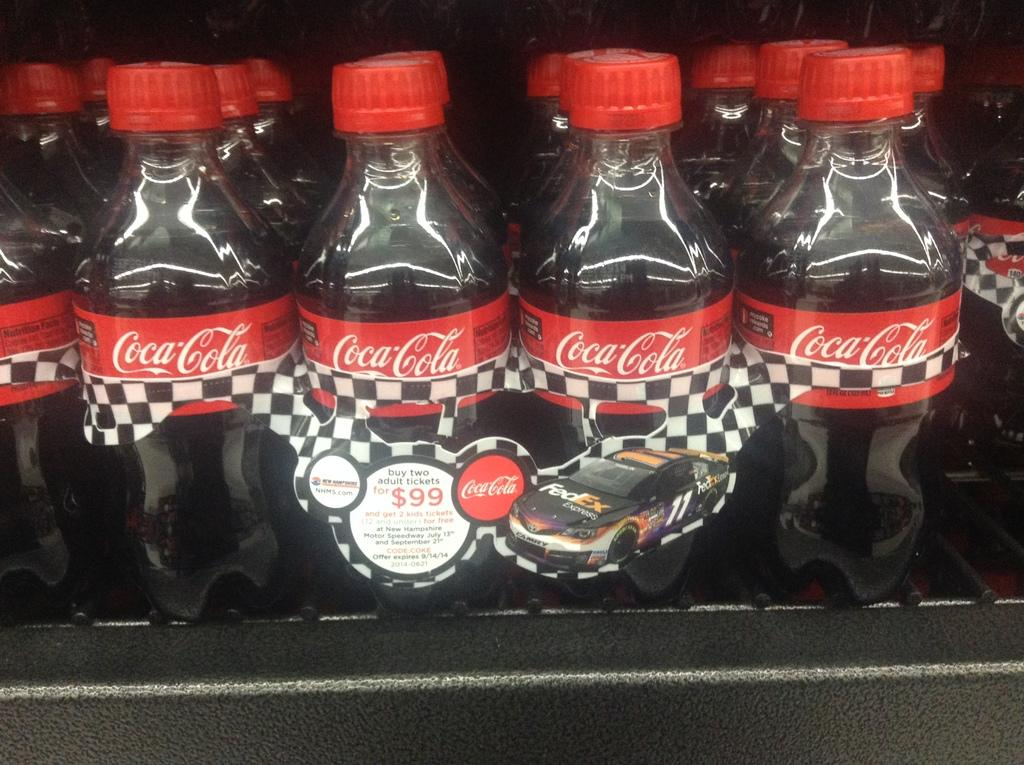What type of items are arranged in the image? There are cool drink bottles arranged in the image. How are the cool drink bottles positioned in the image? The cool drink bottles are arranged in a specific order or pattern. What might be the purpose of arranging the cool drink bottles in this way? The arrangement could be for display, storage, or to make it easier to grab a bottle when needed. What type of pan can be seen in the image? There is no pan present in the image; it only features cool drink bottles. 